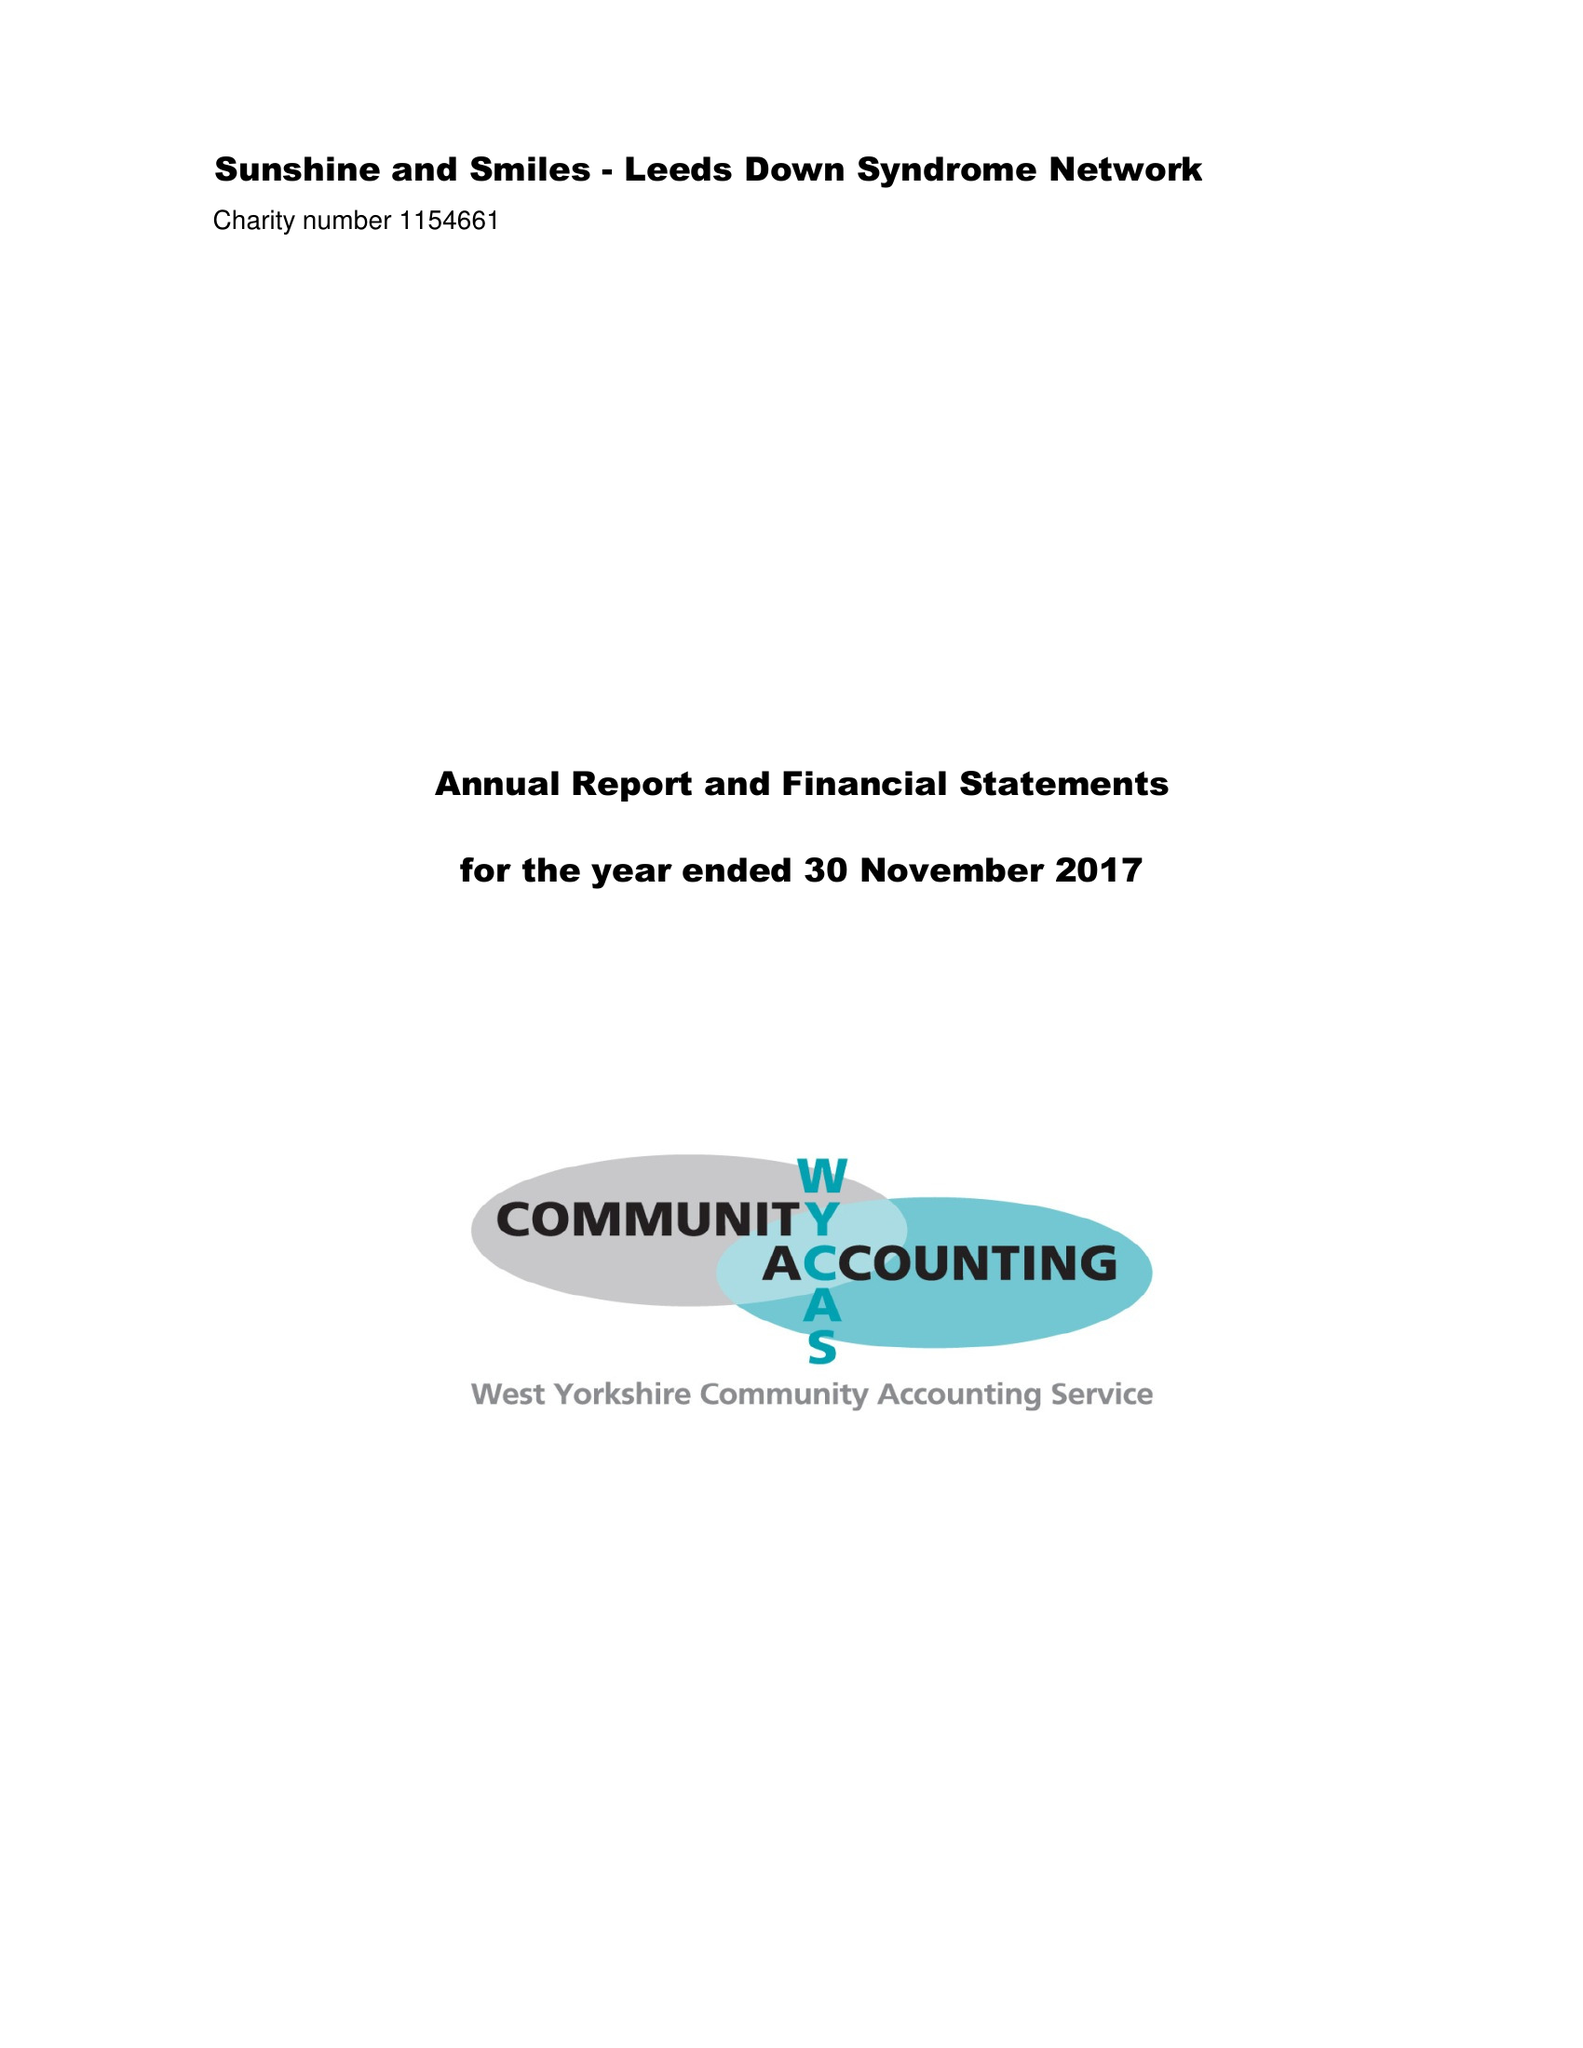What is the value for the charity_number?
Answer the question using a single word or phrase. 1154661 